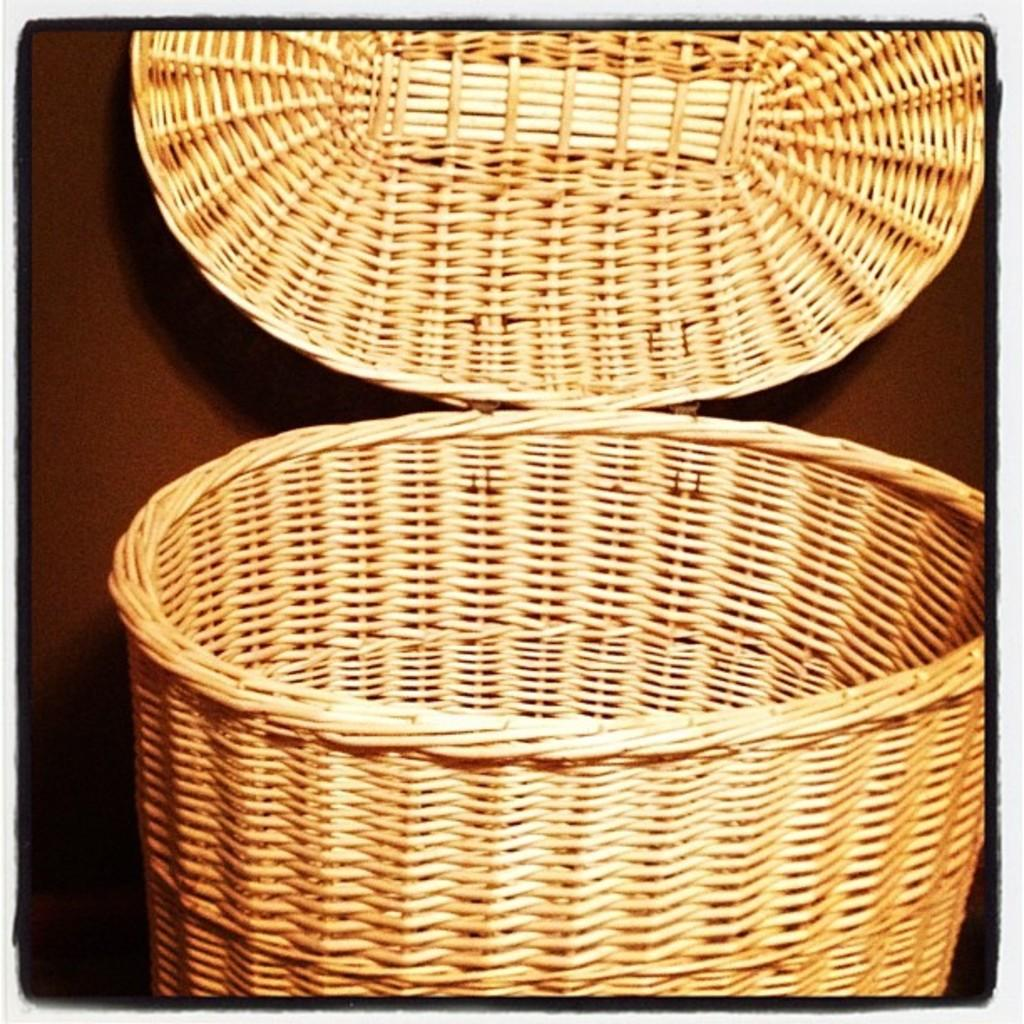What is the main feature of the image? The main feature of the image is a basket in the center. What can be seen around the edges of the image? The image has borders. What is the background of the image? There is a color background in the image. How many drawers are visible in the image? There are no drawers present in the image. What type of houses can be seen in the background of the image? There are no houses visible in the image; it only features a basket and a color background. 